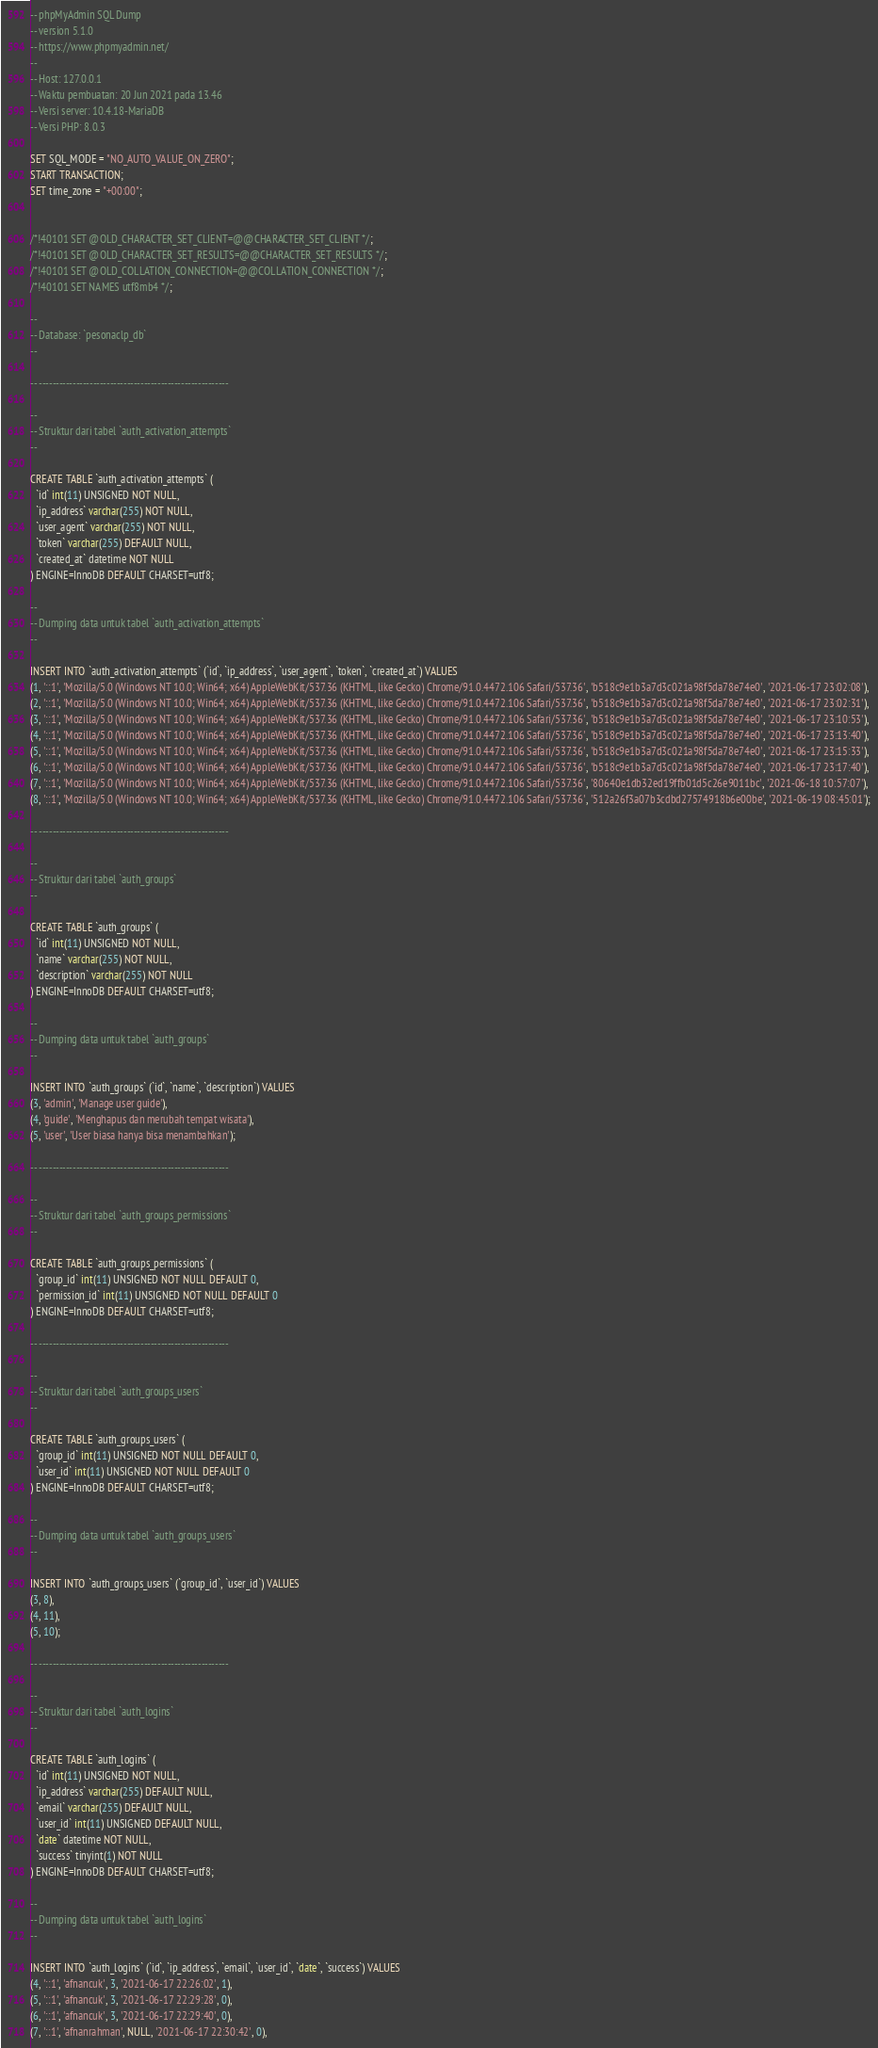Convert code to text. <code><loc_0><loc_0><loc_500><loc_500><_SQL_>-- phpMyAdmin SQL Dump
-- version 5.1.0
-- https://www.phpmyadmin.net/
--
-- Host: 127.0.0.1
-- Waktu pembuatan: 20 Jun 2021 pada 13.46
-- Versi server: 10.4.18-MariaDB
-- Versi PHP: 8.0.3

SET SQL_MODE = "NO_AUTO_VALUE_ON_ZERO";
START TRANSACTION;
SET time_zone = "+00:00";


/*!40101 SET @OLD_CHARACTER_SET_CLIENT=@@CHARACTER_SET_CLIENT */;
/*!40101 SET @OLD_CHARACTER_SET_RESULTS=@@CHARACTER_SET_RESULTS */;
/*!40101 SET @OLD_COLLATION_CONNECTION=@@COLLATION_CONNECTION */;
/*!40101 SET NAMES utf8mb4 */;

--
-- Database: `pesonaclp_db`
--

-- --------------------------------------------------------

--
-- Struktur dari tabel `auth_activation_attempts`
--

CREATE TABLE `auth_activation_attempts` (
  `id` int(11) UNSIGNED NOT NULL,
  `ip_address` varchar(255) NOT NULL,
  `user_agent` varchar(255) NOT NULL,
  `token` varchar(255) DEFAULT NULL,
  `created_at` datetime NOT NULL
) ENGINE=InnoDB DEFAULT CHARSET=utf8;

--
-- Dumping data untuk tabel `auth_activation_attempts`
--

INSERT INTO `auth_activation_attempts` (`id`, `ip_address`, `user_agent`, `token`, `created_at`) VALUES
(1, '::1', 'Mozilla/5.0 (Windows NT 10.0; Win64; x64) AppleWebKit/537.36 (KHTML, like Gecko) Chrome/91.0.4472.106 Safari/537.36', 'b518c9e1b3a7d3c021a98f5da78e74e0', '2021-06-17 23:02:08'),
(2, '::1', 'Mozilla/5.0 (Windows NT 10.0; Win64; x64) AppleWebKit/537.36 (KHTML, like Gecko) Chrome/91.0.4472.106 Safari/537.36', 'b518c9e1b3a7d3c021a98f5da78e74e0', '2021-06-17 23:02:31'),
(3, '::1', 'Mozilla/5.0 (Windows NT 10.0; Win64; x64) AppleWebKit/537.36 (KHTML, like Gecko) Chrome/91.0.4472.106 Safari/537.36', 'b518c9e1b3a7d3c021a98f5da78e74e0', '2021-06-17 23:10:53'),
(4, '::1', 'Mozilla/5.0 (Windows NT 10.0; Win64; x64) AppleWebKit/537.36 (KHTML, like Gecko) Chrome/91.0.4472.106 Safari/537.36', 'b518c9e1b3a7d3c021a98f5da78e74e0', '2021-06-17 23:13:40'),
(5, '::1', 'Mozilla/5.0 (Windows NT 10.0; Win64; x64) AppleWebKit/537.36 (KHTML, like Gecko) Chrome/91.0.4472.106 Safari/537.36', 'b518c9e1b3a7d3c021a98f5da78e74e0', '2021-06-17 23:15:33'),
(6, '::1', 'Mozilla/5.0 (Windows NT 10.0; Win64; x64) AppleWebKit/537.36 (KHTML, like Gecko) Chrome/91.0.4472.106 Safari/537.36', 'b518c9e1b3a7d3c021a98f5da78e74e0', '2021-06-17 23:17:40'),
(7, '::1', 'Mozilla/5.0 (Windows NT 10.0; Win64; x64) AppleWebKit/537.36 (KHTML, like Gecko) Chrome/91.0.4472.106 Safari/537.36', '80640e1db32ed19ffb01d5c26e9011bc', '2021-06-18 10:57:07'),
(8, '::1', 'Mozilla/5.0 (Windows NT 10.0; Win64; x64) AppleWebKit/537.36 (KHTML, like Gecko) Chrome/91.0.4472.106 Safari/537.36', '512a26f3a07b3cdbd27574918b6e00be', '2021-06-19 08:45:01');

-- --------------------------------------------------------

--
-- Struktur dari tabel `auth_groups`
--

CREATE TABLE `auth_groups` (
  `id` int(11) UNSIGNED NOT NULL,
  `name` varchar(255) NOT NULL,
  `description` varchar(255) NOT NULL
) ENGINE=InnoDB DEFAULT CHARSET=utf8;

--
-- Dumping data untuk tabel `auth_groups`
--

INSERT INTO `auth_groups` (`id`, `name`, `description`) VALUES
(3, 'admin', 'Manage user guide'),
(4, 'guide', 'Menghapus dan merubah tempat wisata'),
(5, 'user', 'User biasa hanya bisa menambahkan');

-- --------------------------------------------------------

--
-- Struktur dari tabel `auth_groups_permissions`
--

CREATE TABLE `auth_groups_permissions` (
  `group_id` int(11) UNSIGNED NOT NULL DEFAULT 0,
  `permission_id` int(11) UNSIGNED NOT NULL DEFAULT 0
) ENGINE=InnoDB DEFAULT CHARSET=utf8;

-- --------------------------------------------------------

--
-- Struktur dari tabel `auth_groups_users`
--

CREATE TABLE `auth_groups_users` (
  `group_id` int(11) UNSIGNED NOT NULL DEFAULT 0,
  `user_id` int(11) UNSIGNED NOT NULL DEFAULT 0
) ENGINE=InnoDB DEFAULT CHARSET=utf8;

--
-- Dumping data untuk tabel `auth_groups_users`
--

INSERT INTO `auth_groups_users` (`group_id`, `user_id`) VALUES
(3, 8),
(4, 11),
(5, 10);

-- --------------------------------------------------------

--
-- Struktur dari tabel `auth_logins`
--

CREATE TABLE `auth_logins` (
  `id` int(11) UNSIGNED NOT NULL,
  `ip_address` varchar(255) DEFAULT NULL,
  `email` varchar(255) DEFAULT NULL,
  `user_id` int(11) UNSIGNED DEFAULT NULL,
  `date` datetime NOT NULL,
  `success` tinyint(1) NOT NULL
) ENGINE=InnoDB DEFAULT CHARSET=utf8;

--
-- Dumping data untuk tabel `auth_logins`
--

INSERT INTO `auth_logins` (`id`, `ip_address`, `email`, `user_id`, `date`, `success`) VALUES
(4, '::1', 'afnancuk', 3, '2021-06-17 22:26:02', 1),
(5, '::1', 'afnancuk', 3, '2021-06-17 22:29:28', 0),
(6, '::1', 'afnancuk', 3, '2021-06-17 22:29:40', 0),
(7, '::1', 'afnanrahman', NULL, '2021-06-17 22:30:42', 0),</code> 